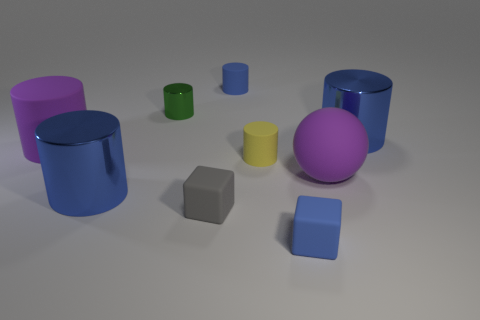What is the shape of the thing that is the same color as the large matte cylinder?
Your answer should be compact. Sphere. Is the ball the same color as the large rubber cylinder?
Give a very brief answer. Yes. How many other large rubber spheres have the same color as the rubber sphere?
Make the answer very short. 0. What is the material of the object that is the same color as the big sphere?
Offer a very short reply. Rubber. There is a blue rubber object that is in front of the blue cylinder on the left side of the tiny gray block; what size is it?
Your response must be concise. Small. Are there any gray things made of the same material as the yellow object?
Keep it short and to the point. Yes. There is a gray block that is the same size as the green shiny cylinder; what is its material?
Ensure brevity in your answer.  Rubber. There is a metal object that is to the right of the gray thing; does it have the same color as the big shiny object on the left side of the green thing?
Provide a short and direct response. Yes. Are there any things that are in front of the large blue thing that is on the left side of the tiny yellow cylinder?
Provide a short and direct response. Yes. There is a metal thing that is to the right of the small gray matte block; is its shape the same as the large metal object left of the small blue cylinder?
Offer a terse response. Yes. 